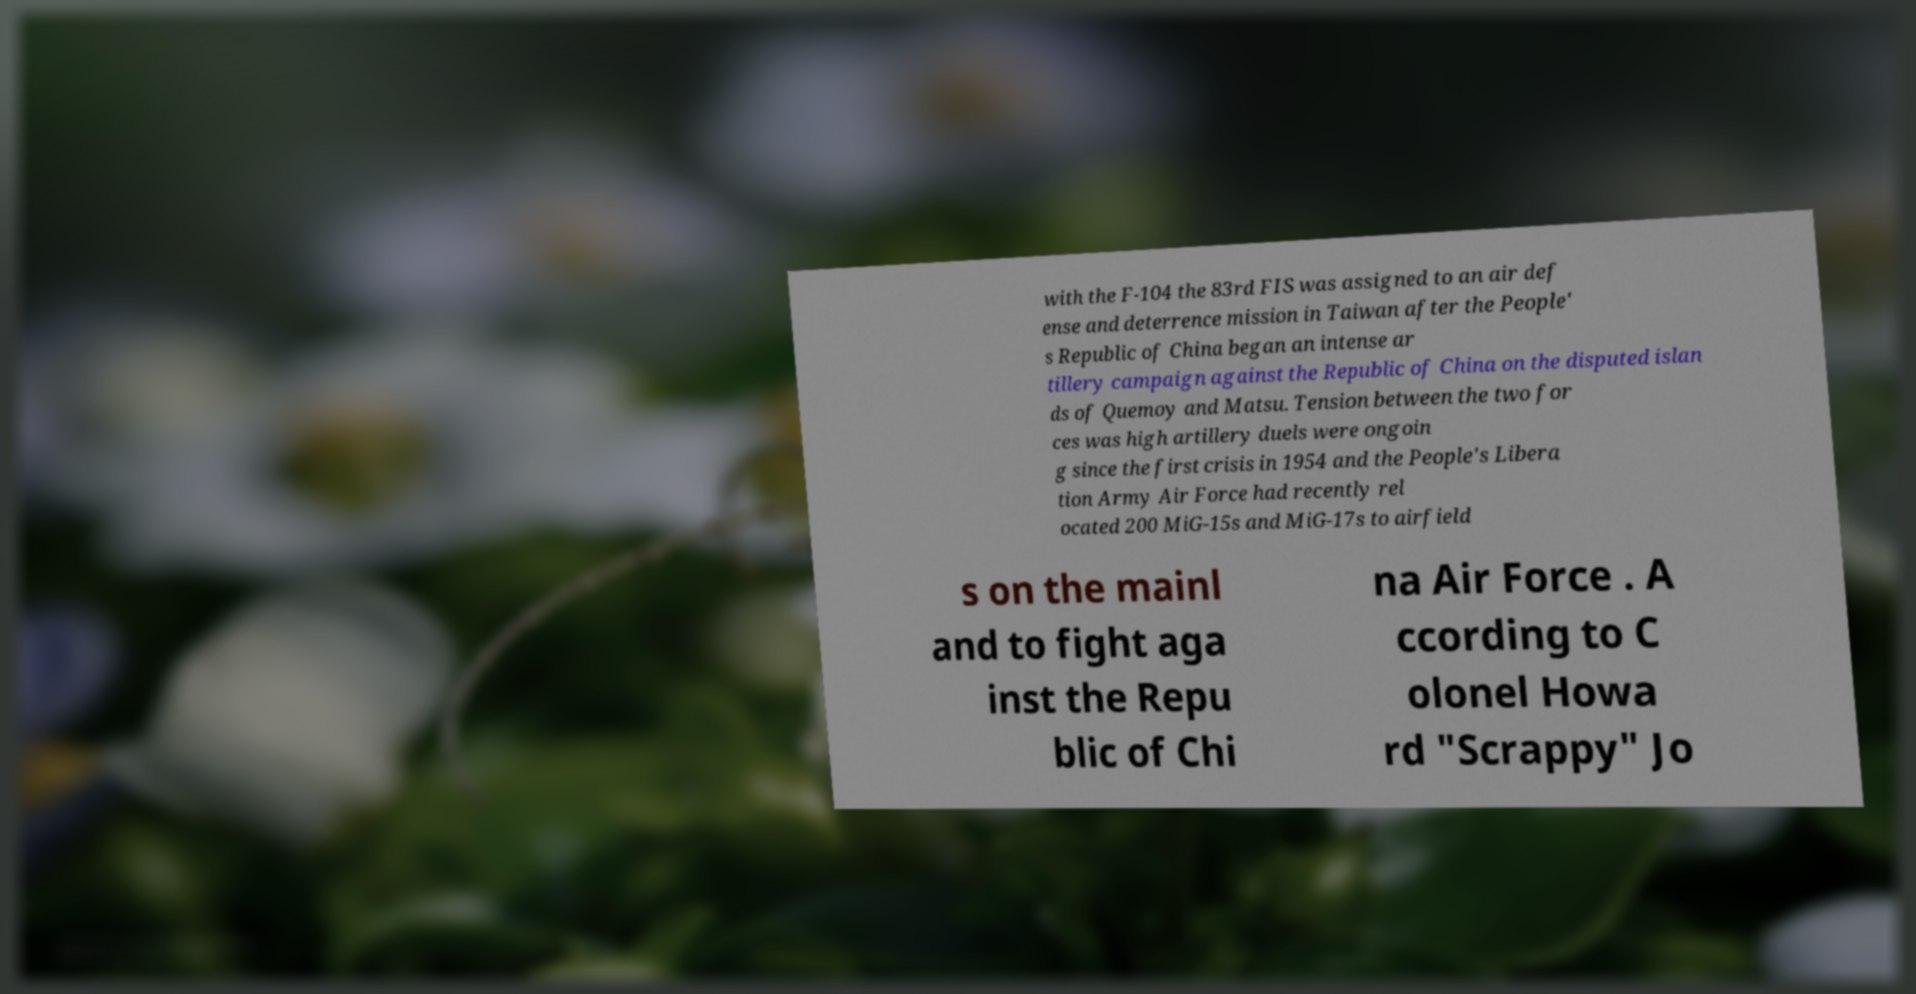Please identify and transcribe the text found in this image. with the F-104 the 83rd FIS was assigned to an air def ense and deterrence mission in Taiwan after the People' s Republic of China began an intense ar tillery campaign against the Republic of China on the disputed islan ds of Quemoy and Matsu. Tension between the two for ces was high artillery duels were ongoin g since the first crisis in 1954 and the People's Libera tion Army Air Force had recently rel ocated 200 MiG-15s and MiG-17s to airfield s on the mainl and to fight aga inst the Repu blic of Chi na Air Force . A ccording to C olonel Howa rd "Scrappy" Jo 